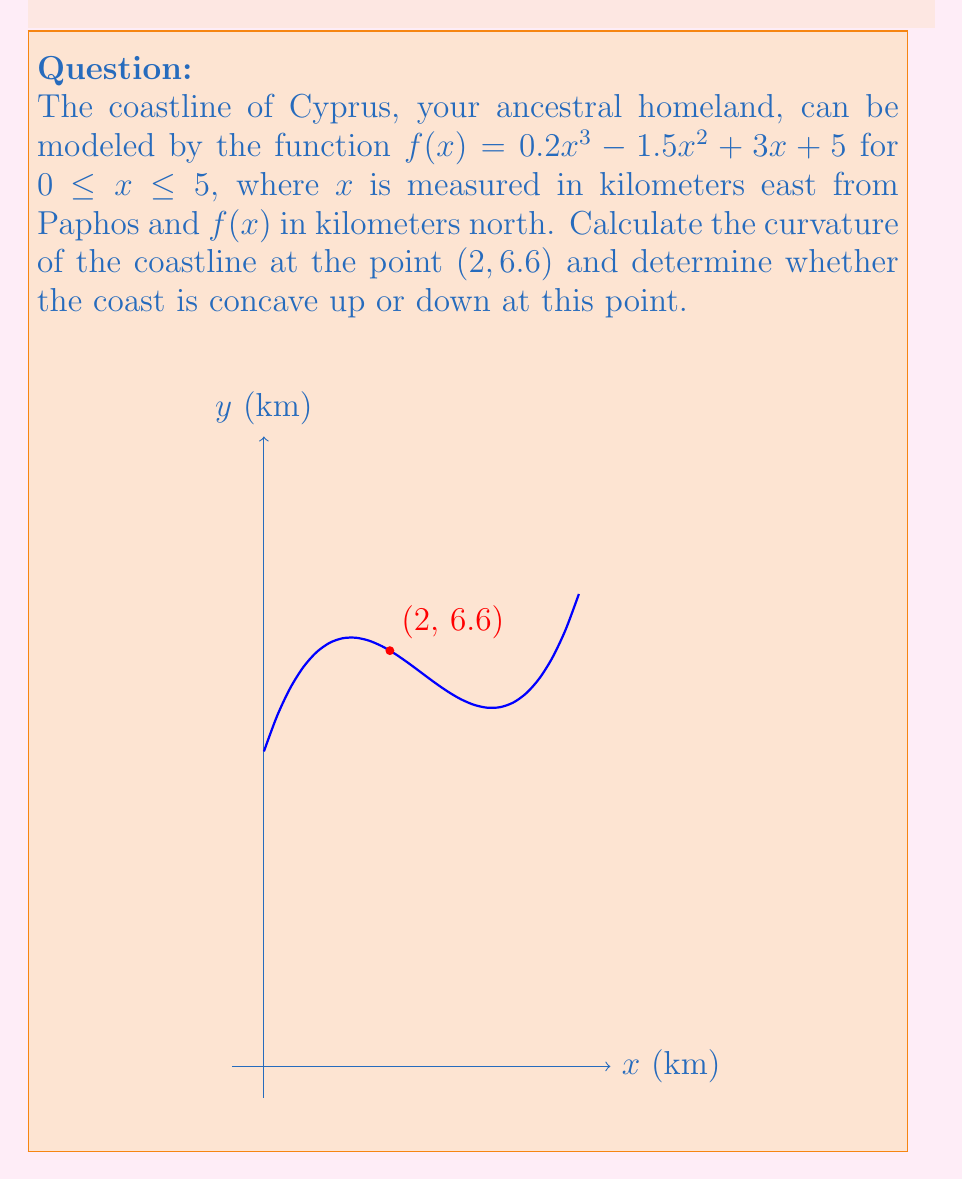Solve this math problem. To analyze the curvature of the coastline, we need to calculate the first and second derivatives of $f(x)$, and then use the curvature formula.

Step 1: Calculate $f'(x)$ and $f''(x)$
$f(x) = 0.2x^3 - 1.5x^2 + 3x + 5$
$f'(x) = 0.6x^2 - 3x + 3$
$f''(x) = 1.2x - 3$

Step 2: Calculate $f'(2)$ and $f''(2)$
$f'(2) = 0.6(2)^2 - 3(2) + 3 = 2.4 - 6 + 3 = -0.6$
$f''(2) = 1.2(2) - 3 = 2.4 - 3 = -0.6$

Step 3: Use the curvature formula for a function in Cartesian coordinates:
$$\kappa = \frac{|f''(x)|}{(1 + [f'(x)]^2)^{3/2}}$$

Substituting the values:
$$\kappa = \frac{|-0.6|}{(1 + [-0.6]^2)^{3/2}} = \frac{0.6}{(1 + 0.36)^{3/2}} = \frac{0.6}{1.36^{3/2}} \approx 0.3375$$

Step 4: Determine concavity
Since $f''(2) = -0.6 < 0$, the coastline is concave down at x = 2.
Answer: Curvature ≈ 0.3375; Concave down 